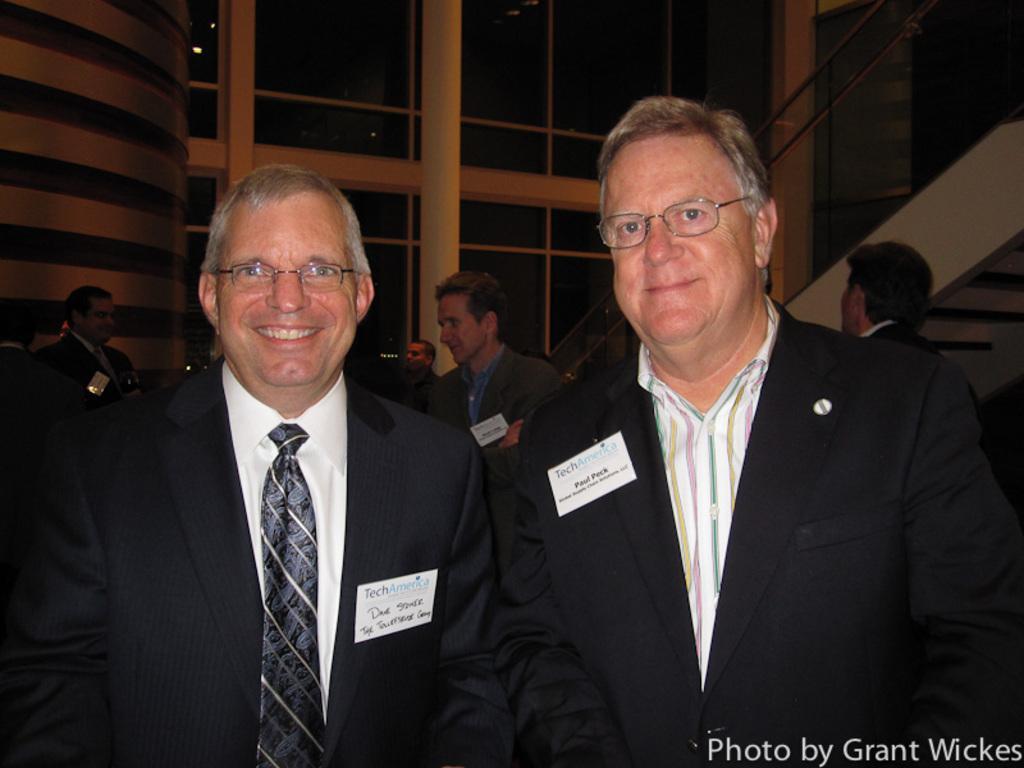In one or two sentences, can you explain what this image depicts? In this image there are two people standing with a smile on their face, behind them there are a few other people, to the right of the image there is a staircase to the top of the building. 